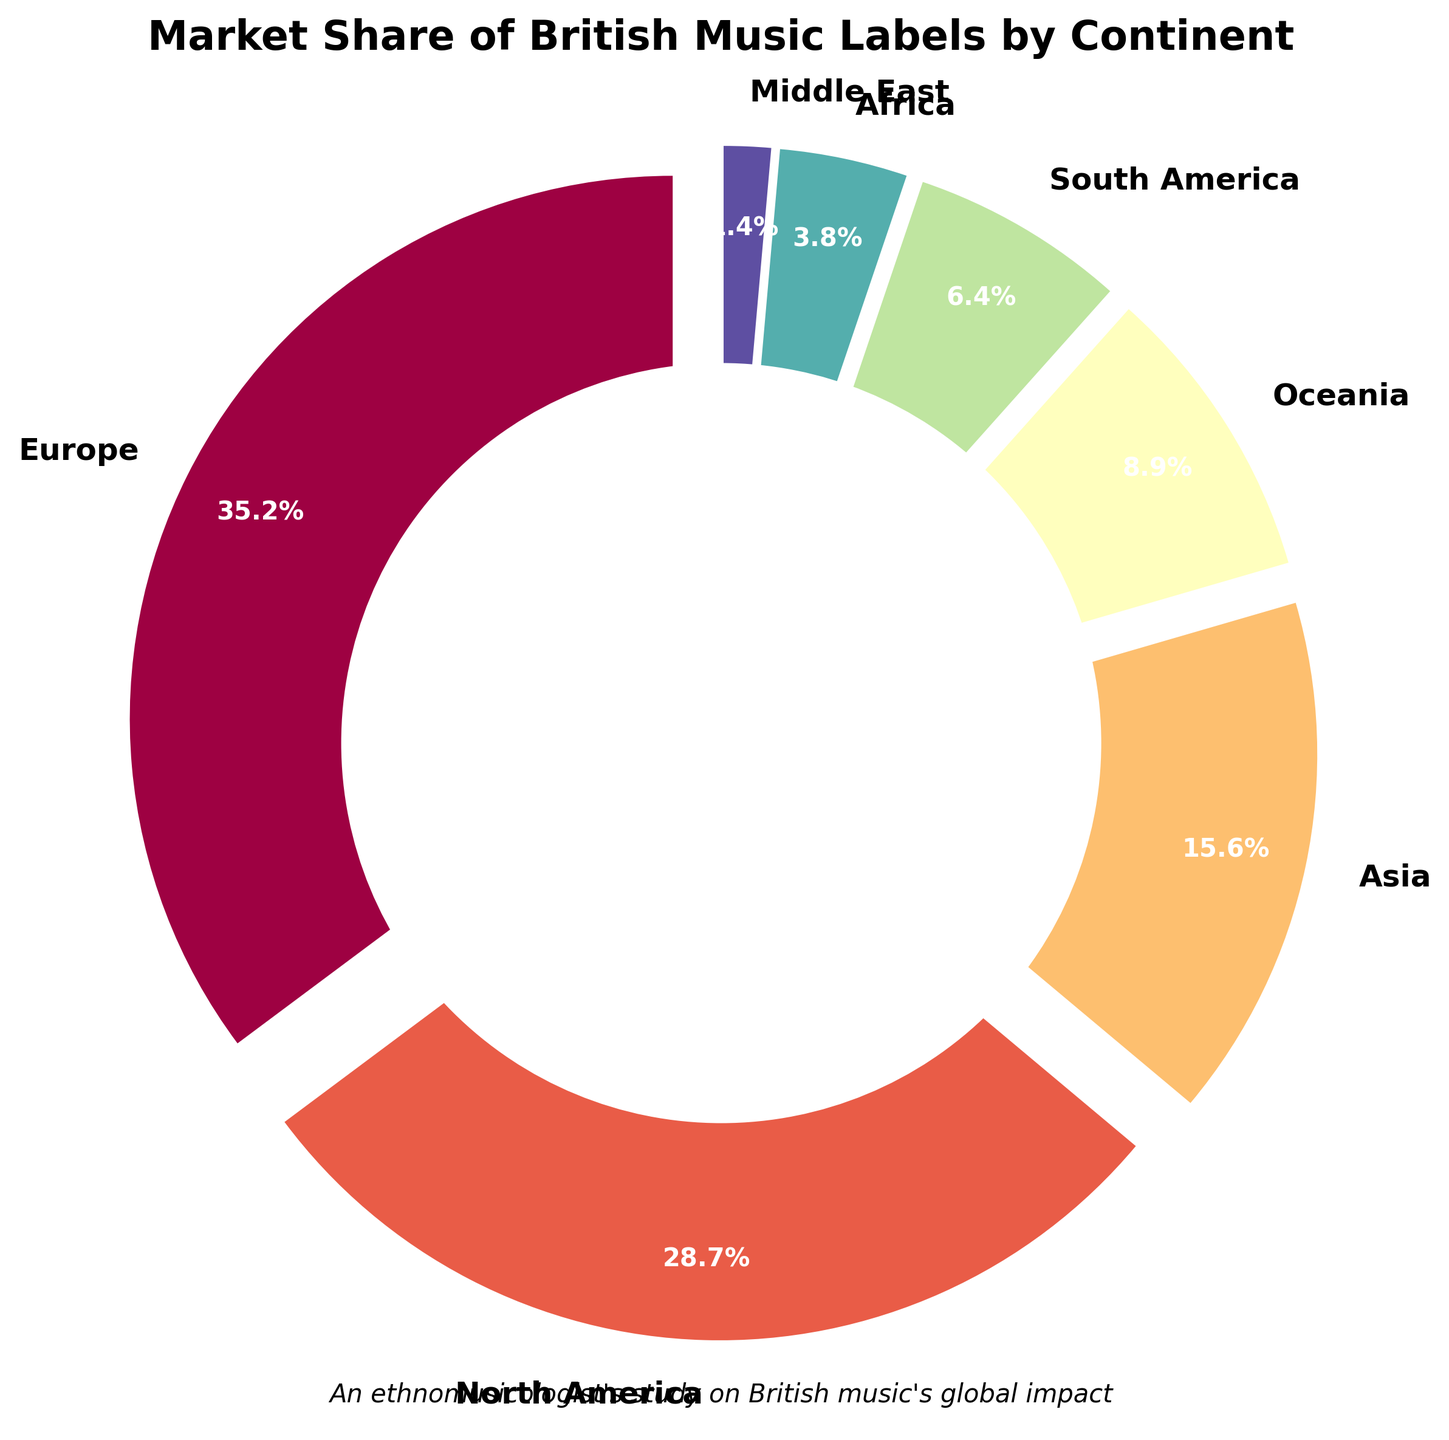Which continent holds the highest market share for British music labels? The figure shows that Europe has the largest section of the pie chart, indicating it holds the highest market share among the continents.
Answer: Europe How much larger is the market share of British music labels in Europe compared to Africa? To find the difference, subtract Africa's market share (3.8%) from Europe's market share (35.2%): 35.2% - 3.8% = 31.4%.
Answer: 31.4% Which two continents combined have a market share closest to that of North America? North America's market share is 28.7%. To find two continents where their combined share is closest to this, add the percentages of different pairs. Asia (15.6%) + Oceania (8.9%) gives 24.5%, which is closest to 28.7%.
Answer: Asia and Oceania What is the total market share for British music labels in the Southern Hemisphere (South America, Africa, Oceania)? Add the market shares: South America (6.4%) + Africa (3.8%) + Oceania (8.9%) = 19.1%.
Answer: 19.1% Which continent has a smaller market share than Oceania but larger than the Middle East? Look for the market share that falls between Oceania's 8.9% and the Middle East's 1.4%. South America, with a market share of 6.4%, fits this criterion.
Answer: South America Compare the market shares of continents where British music labels have less than 10%. Which has the smallest share? From the pie chart, the Middle East, Africa, and South America have less than 10%. Out of these, the Middle East has the smallest share at 1.4%.
Answer: Middle East What fraction of the global market share is held by British music labels in Europe and North America combined? Add the percentages of Europe and North America: Europe (35.2%) + North America (28.7%) = 63.9%. The fraction is 63.9/100 or approximately 64/100.
Answer: 0.639 or 63.9% How much more market share does North America have compared to Asia? Subtract Asia's market share (15.6%) from North America's market share (28.7%): 28.7% - 15.6% = 13.1%.
Answer: 13.1% What is the average market share of British music labels among all seven continents shown? Add all market shares and divide by the number of continents: (35.2% + 28.7% + 15.6% + 8.9% + 6.4% + 3.8% + 1.4%) / 7 = 100 / 7 ≈ 14.3%.
Answer: 14.3% Which regions are represented with a market share percentage greater than the total for South America and Africa combined? Sum the market shares of South America and Africa: 6.4% + 3.8% = 10.2%. The regions with more than 10.2% are Europe (35.2%), North America (28.7%), and Asia (15.6%).
Answer: Europe, North America, and Asia 